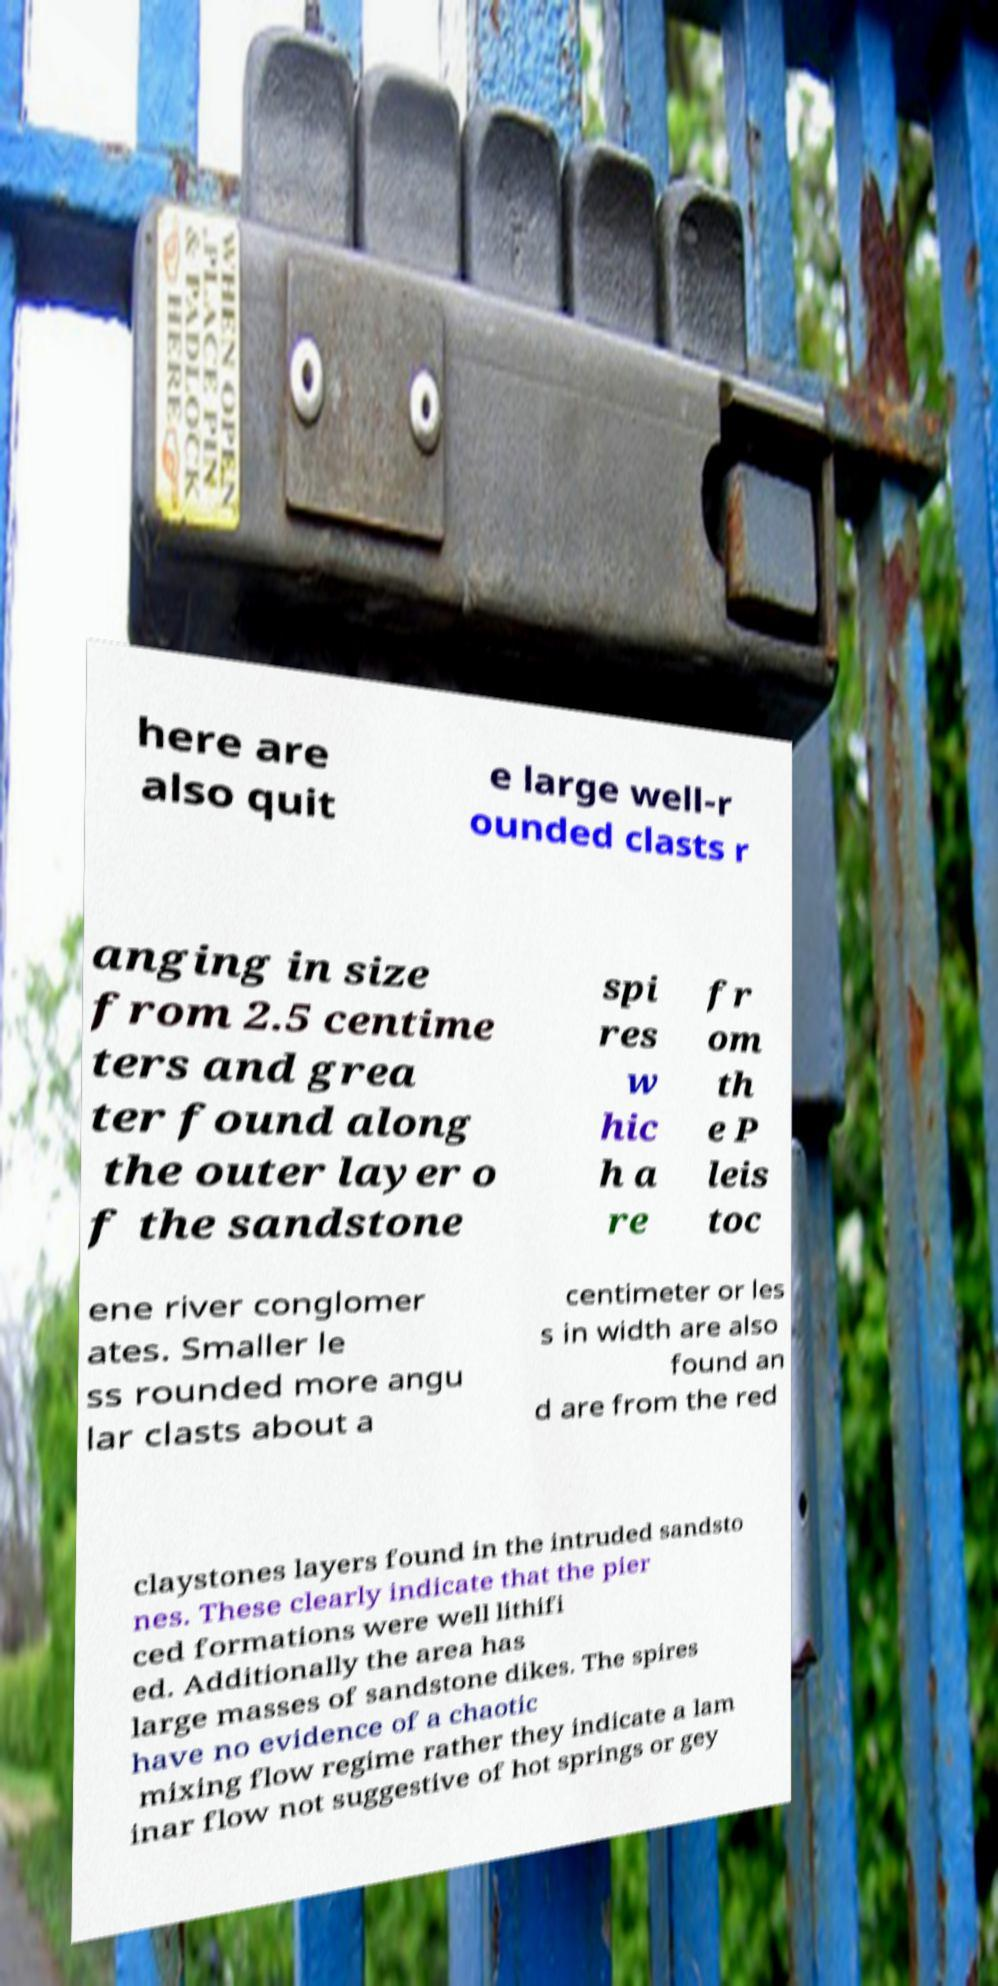Can you read and provide the text displayed in the image?This photo seems to have some interesting text. Can you extract and type it out for me? here are also quit e large well-r ounded clasts r anging in size from 2.5 centime ters and grea ter found along the outer layer o f the sandstone spi res w hic h a re fr om th e P leis toc ene river conglomer ates. Smaller le ss rounded more angu lar clasts about a centimeter or les s in width are also found an d are from the red claystones layers found in the intruded sandsto nes. These clearly indicate that the pier ced formations were well lithifi ed. Additionally the area has large masses of sandstone dikes. The spires have no evidence of a chaotic mixing flow regime rather they indicate a lam inar flow not suggestive of hot springs or gey 